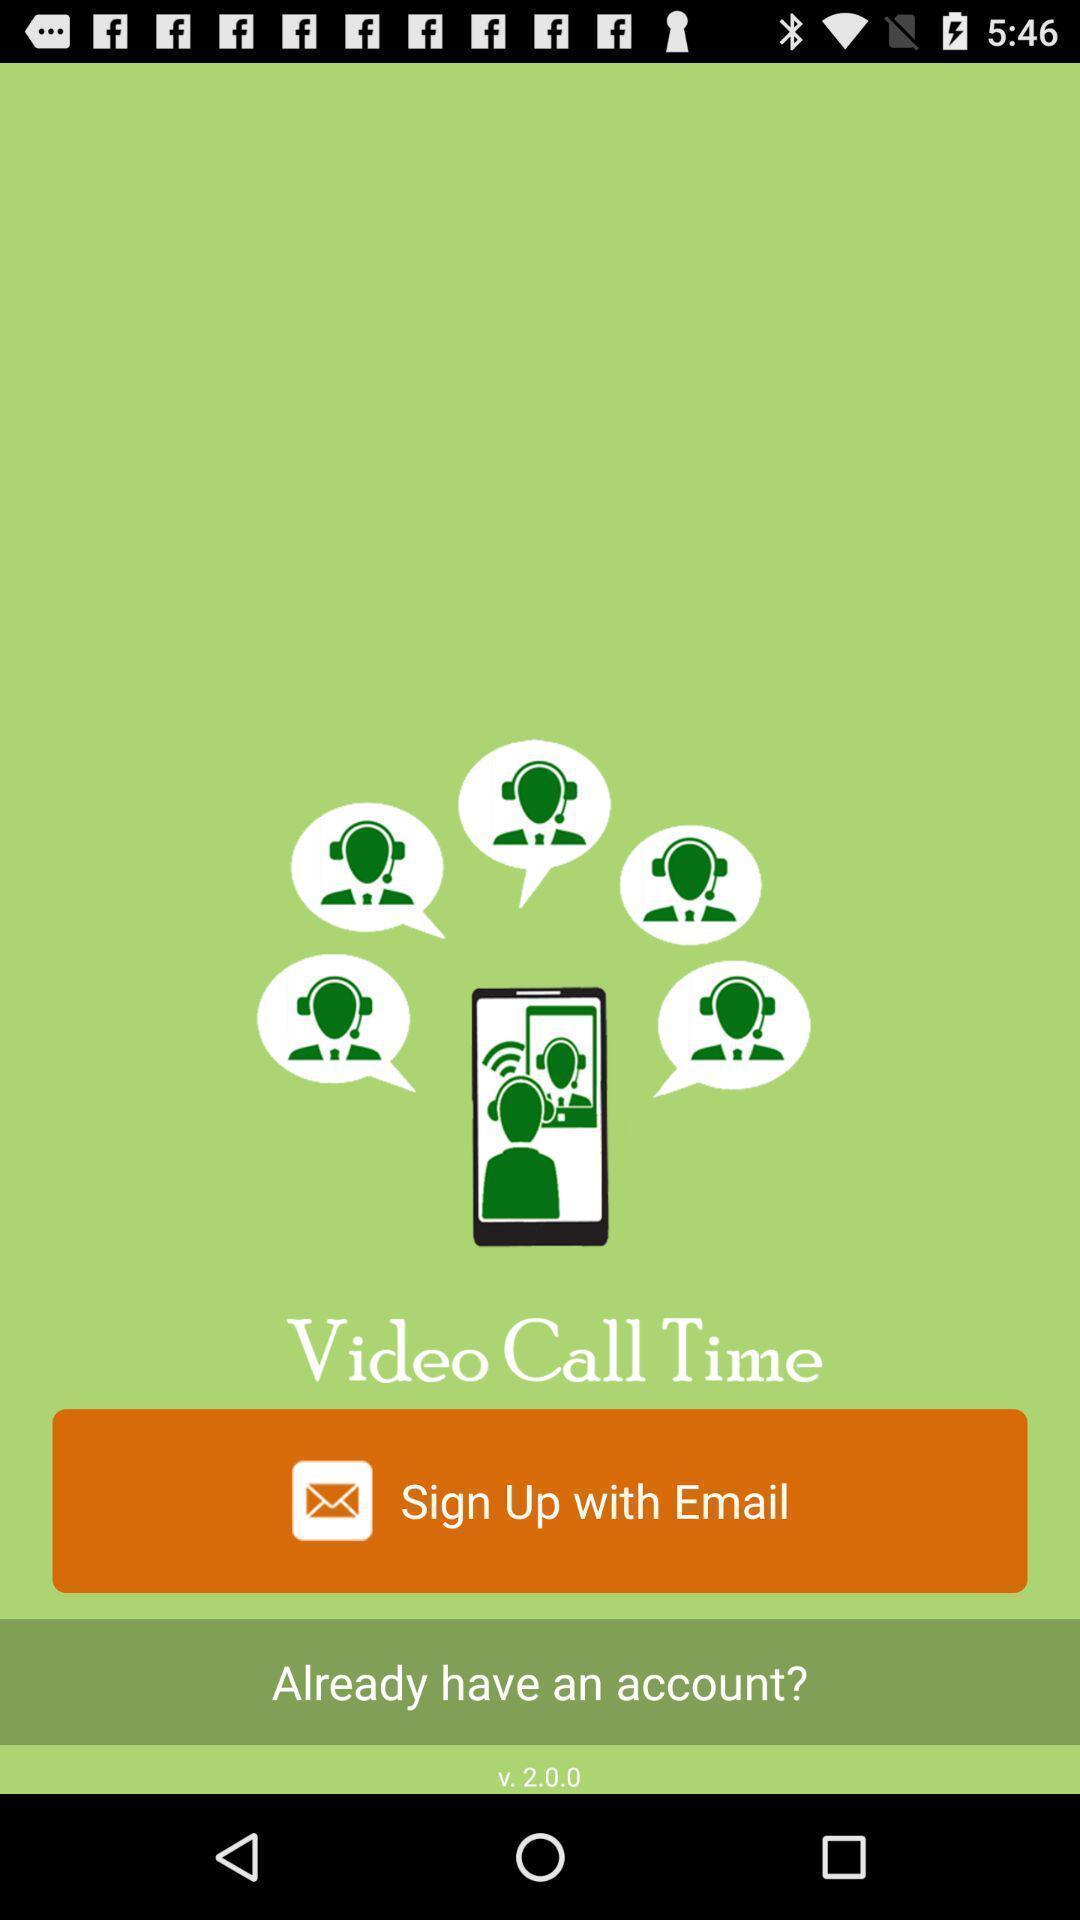Describe the content in this image. Welcome page with option to sign up. 